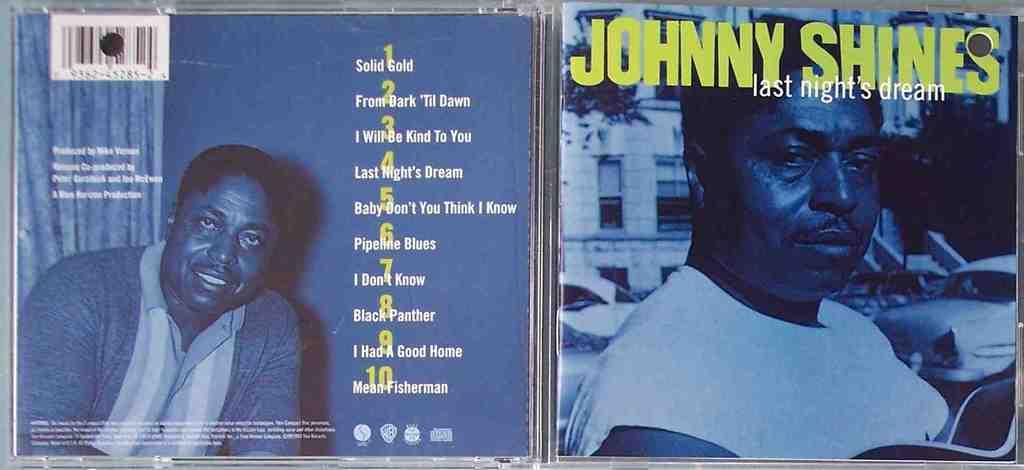What type of items are depicted on the cover pages in the image? The image contains cover pages of DVD boxes. Can you describe the images on the DVD boxes? There are images of two people on the DVD boxes. What else can be seen on the DVD boxes besides the images? There is written matter on the DVD boxes. Can you tell me how many women are standing near the volcano in the image? There is no volcano or woman present in the image; it features cover pages of DVD boxes with images of two people. What type of rice is being cooked in the image? There is no rice present in the image. 